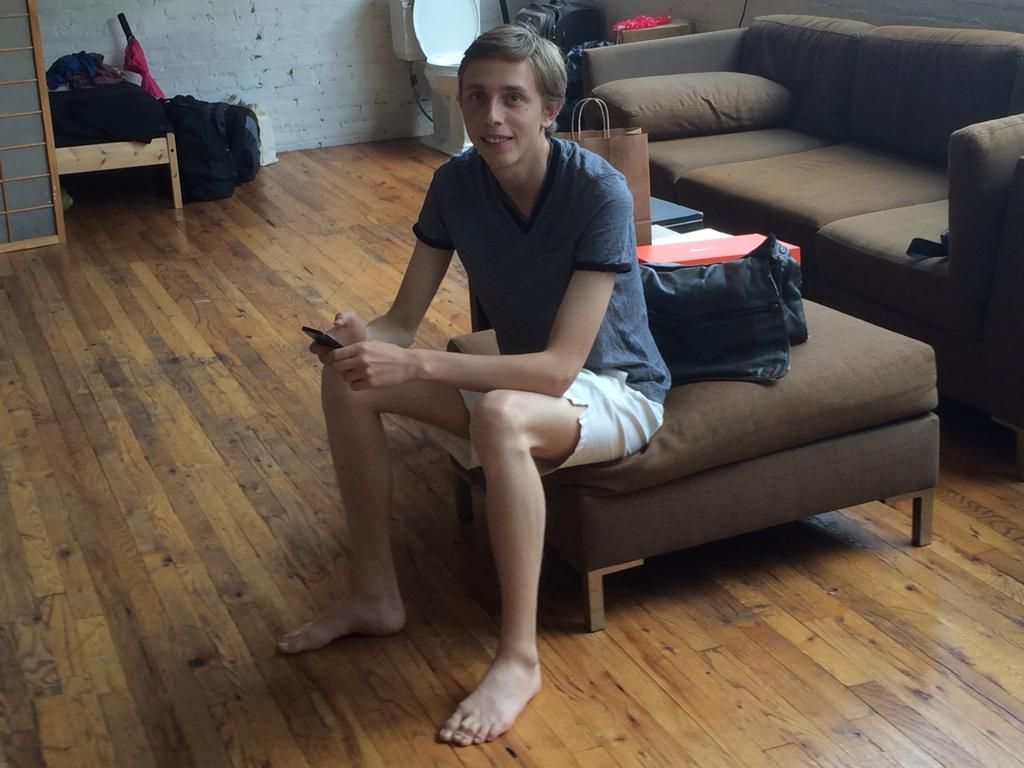Who is the main subject in the image? There is a boy in the image. What is the boy doing in the image? The boy is sitting on a sofa table. What can be seen behind the boy? There is a bag behind the boy. What is the boy holding in the image? The boy is holding an object. What type of wax is being used to create a sculpture on the tray in the image? There is no tray or wax present in the image. What historical event is the boy discussing with the object he is holding? The image does not provide any information about a historical event or a discussion about it. 